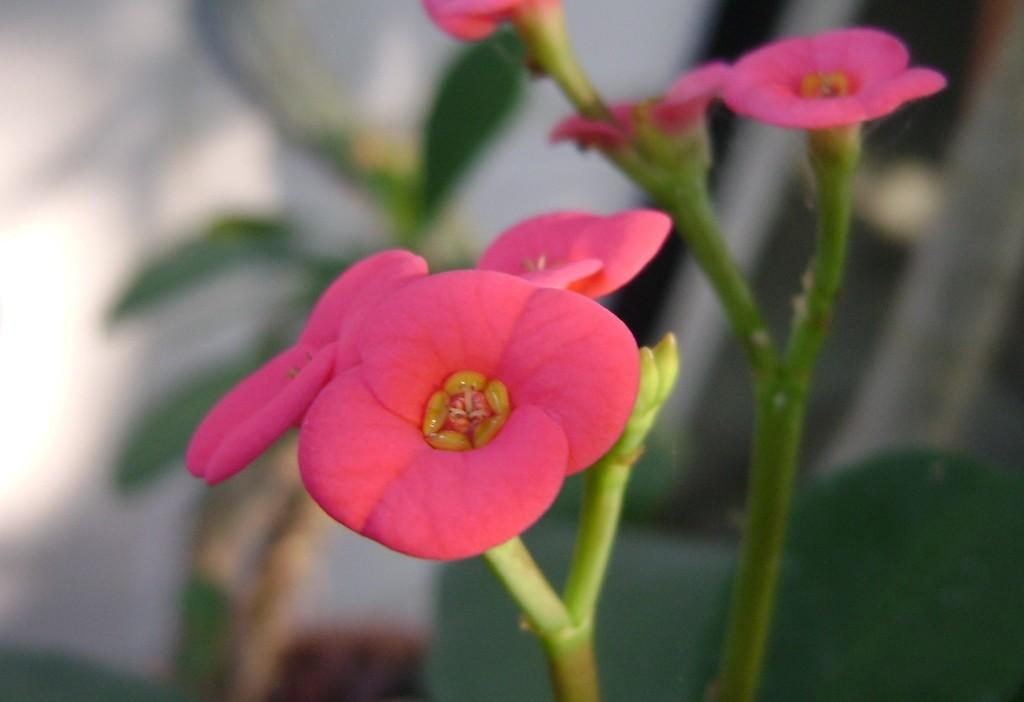What type of living organisms can be seen in the image? There are flowers in the image. What part of the flowers connects them to the ground or container? The flowers have stems. Can you describe the background of the image? The background of the image is blurred. What type of flesh can be seen on the plant in the image? There is no flesh or plant present in the image; it features flowers with stems. 